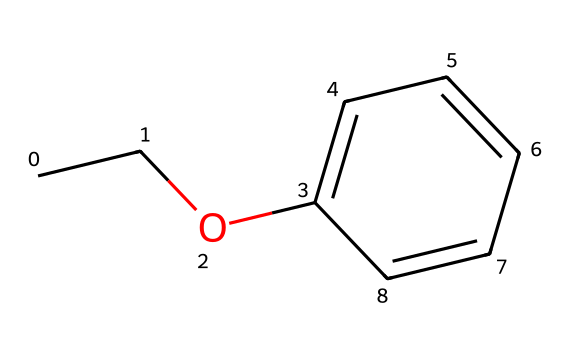What is the main functional group present in ethyl phenyl ether? The structure includes an ether functional group characterized by the presence of an oxygen atom connecting two carbon-containing groups, which in this case are ethyl and phenyl groups.
Answer: ether How many carbon atoms are in ethyl phenyl ether? By analyzing the structure, there are a total of eight carbon atoms: two from the ethyl group (CC) and six from the phenyl group (c1ccccc1).
Answer: eight What is the total number of hydrogen atoms in ethyl phenyl ether? In the structure, the ethyl group contributes five hydrogen atoms (C2H5), while the phenyl group provides five hydrogen atoms (C6H5). Summing these gives a total of ten hydrogen atoms.
Answer: ten How does the structure of ethyl phenyl ether suggest its use in perfumes? The aromatic phenyl group and the ether bond provide stability and pleasant fragrance characteristics, making it suitable for use in perfumes. The phenyl group contributes to a complex scent profile desired in fragrance formulations.
Answer: pleasant aroma What type of compound is ethyl phenyl ether specifically classified as? The structure features ether connectivity between two carbon groups with specific aromatic characteristics, confirming its classification as an ether compound.
Answer: ether What is the boiling point trend for ethers like ethyl phenyl ether compared to alcohols? Ethers typically have lower boiling points than corresponding alcohols because ethers lack hydrogen bonding between molecules, while alcohols have significant hydrogen bonding, resulting in higher boiling points.
Answer: lower boiling points Does ethyl phenyl ether show any special reactivity due to its structure? Ethers, including ethyl phenyl ether, are generally less reactive than other functional groups but can undergo cleavage reactions under strong acidic conditions or with specific reagents, indicating a moderate level of reactivity.
Answer: moderate reactivity 